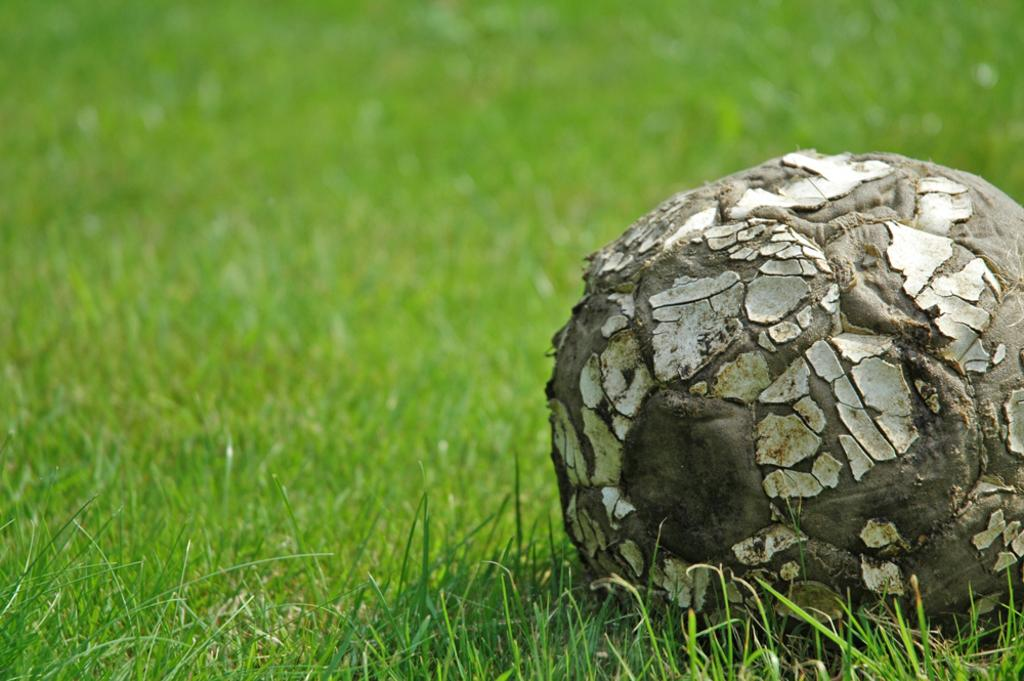What type of vegetation is in the center of the image? There is grass in the center of the image. What object is also present in the center of the image? There is a ball in the center of the image. What type of wine is being served at the surprise education event in the image? There is no wine, surprise, or education event present in the image; it only features grass and a ball in the center. 